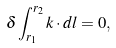<formula> <loc_0><loc_0><loc_500><loc_500>\delta \int _ { { r } _ { 1 } } ^ { { r } _ { 2 } } k \cdot d l = 0 ,</formula> 